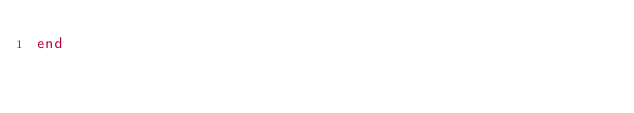<code> <loc_0><loc_0><loc_500><loc_500><_Ruby_>end
</code> 